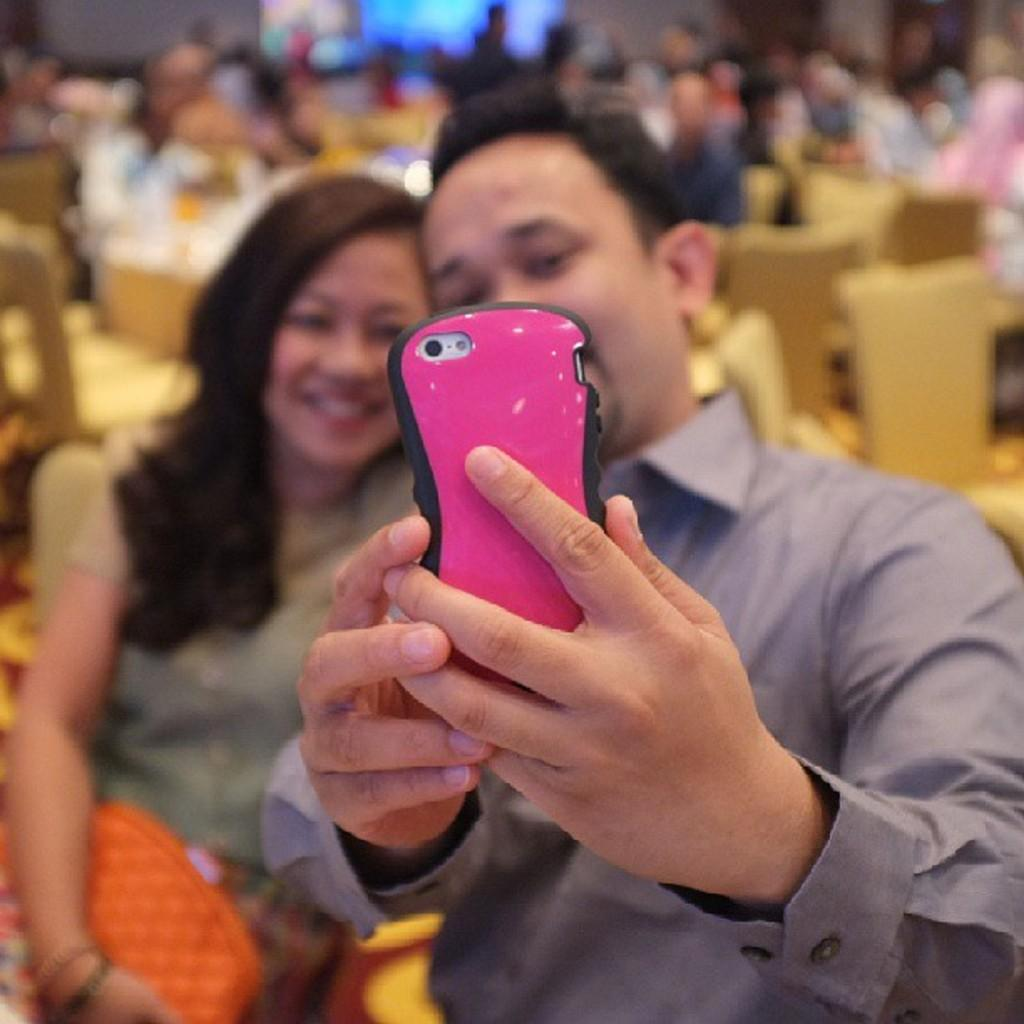Who is present in the image? There is a man and a woman in the image. What are the man and woman doing in the image? The man and woman are taking a selfie with a mobile. What can be seen in the background of the image? There are chairs in the background of the image, and people are sitting on the chairs. How is the background of the image depicted? The background is blurred. What type of powder is being used by the sister in the image? There is no sister present in the image, and no powder is being used. What type of crack can be seen on the mobile in the image? There is no crack visible on the mobile in the image. 